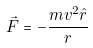Convert formula to latex. <formula><loc_0><loc_0><loc_500><loc_500>\vec { F } = - \frac { m v ^ { 2 } \hat { r } } { r }</formula> 